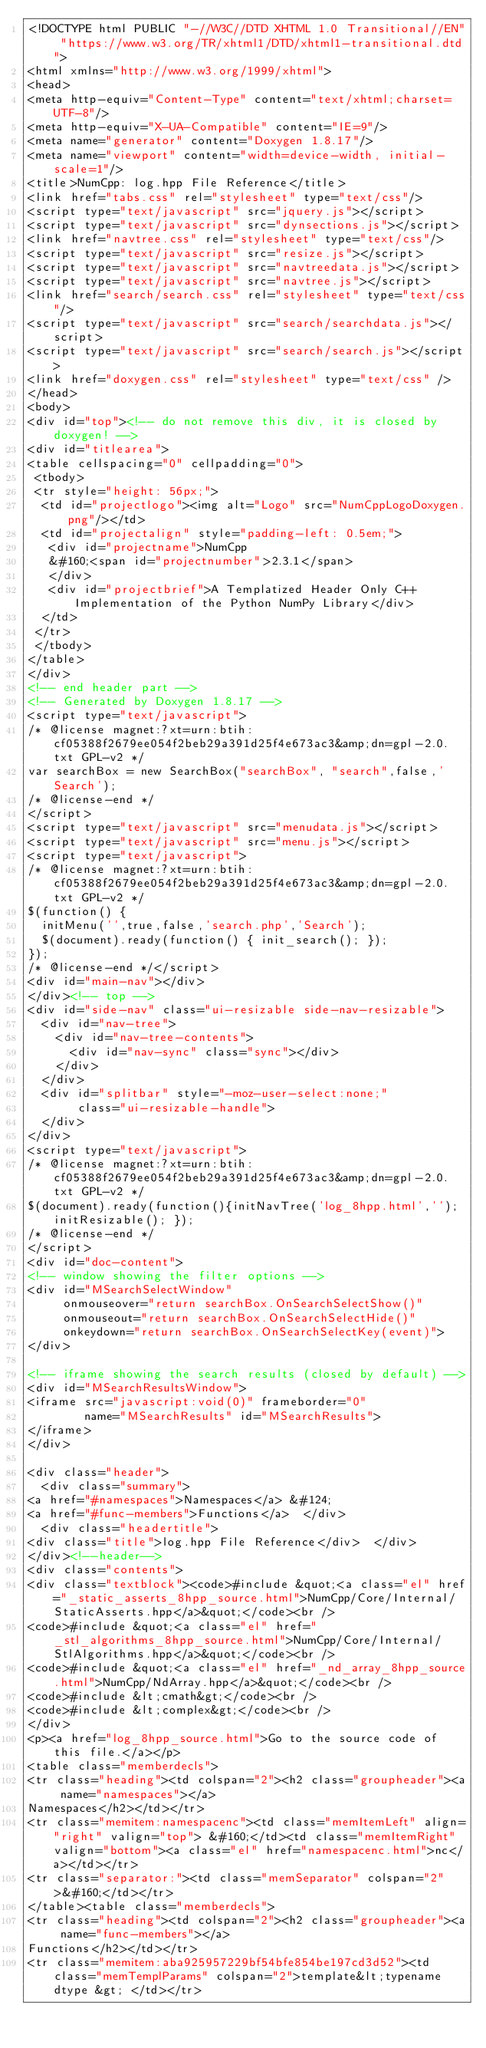Convert code to text. <code><loc_0><loc_0><loc_500><loc_500><_HTML_><!DOCTYPE html PUBLIC "-//W3C//DTD XHTML 1.0 Transitional//EN" "https://www.w3.org/TR/xhtml1/DTD/xhtml1-transitional.dtd">
<html xmlns="http://www.w3.org/1999/xhtml">
<head>
<meta http-equiv="Content-Type" content="text/xhtml;charset=UTF-8"/>
<meta http-equiv="X-UA-Compatible" content="IE=9"/>
<meta name="generator" content="Doxygen 1.8.17"/>
<meta name="viewport" content="width=device-width, initial-scale=1"/>
<title>NumCpp: log.hpp File Reference</title>
<link href="tabs.css" rel="stylesheet" type="text/css"/>
<script type="text/javascript" src="jquery.js"></script>
<script type="text/javascript" src="dynsections.js"></script>
<link href="navtree.css" rel="stylesheet" type="text/css"/>
<script type="text/javascript" src="resize.js"></script>
<script type="text/javascript" src="navtreedata.js"></script>
<script type="text/javascript" src="navtree.js"></script>
<link href="search/search.css" rel="stylesheet" type="text/css"/>
<script type="text/javascript" src="search/searchdata.js"></script>
<script type="text/javascript" src="search/search.js"></script>
<link href="doxygen.css" rel="stylesheet" type="text/css" />
</head>
<body>
<div id="top"><!-- do not remove this div, it is closed by doxygen! -->
<div id="titlearea">
<table cellspacing="0" cellpadding="0">
 <tbody>
 <tr style="height: 56px;">
  <td id="projectlogo"><img alt="Logo" src="NumCppLogoDoxygen.png"/></td>
  <td id="projectalign" style="padding-left: 0.5em;">
   <div id="projectname">NumCpp
   &#160;<span id="projectnumber">2.3.1</span>
   </div>
   <div id="projectbrief">A Templatized Header Only C++ Implementation of the Python NumPy Library</div>
  </td>
 </tr>
 </tbody>
</table>
</div>
<!-- end header part -->
<!-- Generated by Doxygen 1.8.17 -->
<script type="text/javascript">
/* @license magnet:?xt=urn:btih:cf05388f2679ee054f2beb29a391d25f4e673ac3&amp;dn=gpl-2.0.txt GPL-v2 */
var searchBox = new SearchBox("searchBox", "search",false,'Search');
/* @license-end */
</script>
<script type="text/javascript" src="menudata.js"></script>
<script type="text/javascript" src="menu.js"></script>
<script type="text/javascript">
/* @license magnet:?xt=urn:btih:cf05388f2679ee054f2beb29a391d25f4e673ac3&amp;dn=gpl-2.0.txt GPL-v2 */
$(function() {
  initMenu('',true,false,'search.php','Search');
  $(document).ready(function() { init_search(); });
});
/* @license-end */</script>
<div id="main-nav"></div>
</div><!-- top -->
<div id="side-nav" class="ui-resizable side-nav-resizable">
  <div id="nav-tree">
    <div id="nav-tree-contents">
      <div id="nav-sync" class="sync"></div>
    </div>
  </div>
  <div id="splitbar" style="-moz-user-select:none;" 
       class="ui-resizable-handle">
  </div>
</div>
<script type="text/javascript">
/* @license magnet:?xt=urn:btih:cf05388f2679ee054f2beb29a391d25f4e673ac3&amp;dn=gpl-2.0.txt GPL-v2 */
$(document).ready(function(){initNavTree('log_8hpp.html',''); initResizable(); });
/* @license-end */
</script>
<div id="doc-content">
<!-- window showing the filter options -->
<div id="MSearchSelectWindow"
     onmouseover="return searchBox.OnSearchSelectShow()"
     onmouseout="return searchBox.OnSearchSelectHide()"
     onkeydown="return searchBox.OnSearchSelectKey(event)">
</div>

<!-- iframe showing the search results (closed by default) -->
<div id="MSearchResultsWindow">
<iframe src="javascript:void(0)" frameborder="0" 
        name="MSearchResults" id="MSearchResults">
</iframe>
</div>

<div class="header">
  <div class="summary">
<a href="#namespaces">Namespaces</a> &#124;
<a href="#func-members">Functions</a>  </div>
  <div class="headertitle">
<div class="title">log.hpp File Reference</div>  </div>
</div><!--header-->
<div class="contents">
<div class="textblock"><code>#include &quot;<a class="el" href="_static_asserts_8hpp_source.html">NumCpp/Core/Internal/StaticAsserts.hpp</a>&quot;</code><br />
<code>#include &quot;<a class="el" href="_stl_algorithms_8hpp_source.html">NumCpp/Core/Internal/StlAlgorithms.hpp</a>&quot;</code><br />
<code>#include &quot;<a class="el" href="_nd_array_8hpp_source.html">NumCpp/NdArray.hpp</a>&quot;</code><br />
<code>#include &lt;cmath&gt;</code><br />
<code>#include &lt;complex&gt;</code><br />
</div>
<p><a href="log_8hpp_source.html">Go to the source code of this file.</a></p>
<table class="memberdecls">
<tr class="heading"><td colspan="2"><h2 class="groupheader"><a name="namespaces"></a>
Namespaces</h2></td></tr>
<tr class="memitem:namespacenc"><td class="memItemLeft" align="right" valign="top"> &#160;</td><td class="memItemRight" valign="bottom"><a class="el" href="namespacenc.html">nc</a></td></tr>
<tr class="separator:"><td class="memSeparator" colspan="2">&#160;</td></tr>
</table><table class="memberdecls">
<tr class="heading"><td colspan="2"><h2 class="groupheader"><a name="func-members"></a>
Functions</h2></td></tr>
<tr class="memitem:aba925957229bf54bfe854be197cd3d52"><td class="memTemplParams" colspan="2">template&lt;typename dtype &gt; </td></tr></code> 